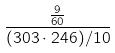<formula> <loc_0><loc_0><loc_500><loc_500>\frac { \frac { 9 } { 6 0 } } { ( 3 0 3 \cdot 2 4 6 ) / 1 0 }</formula> 